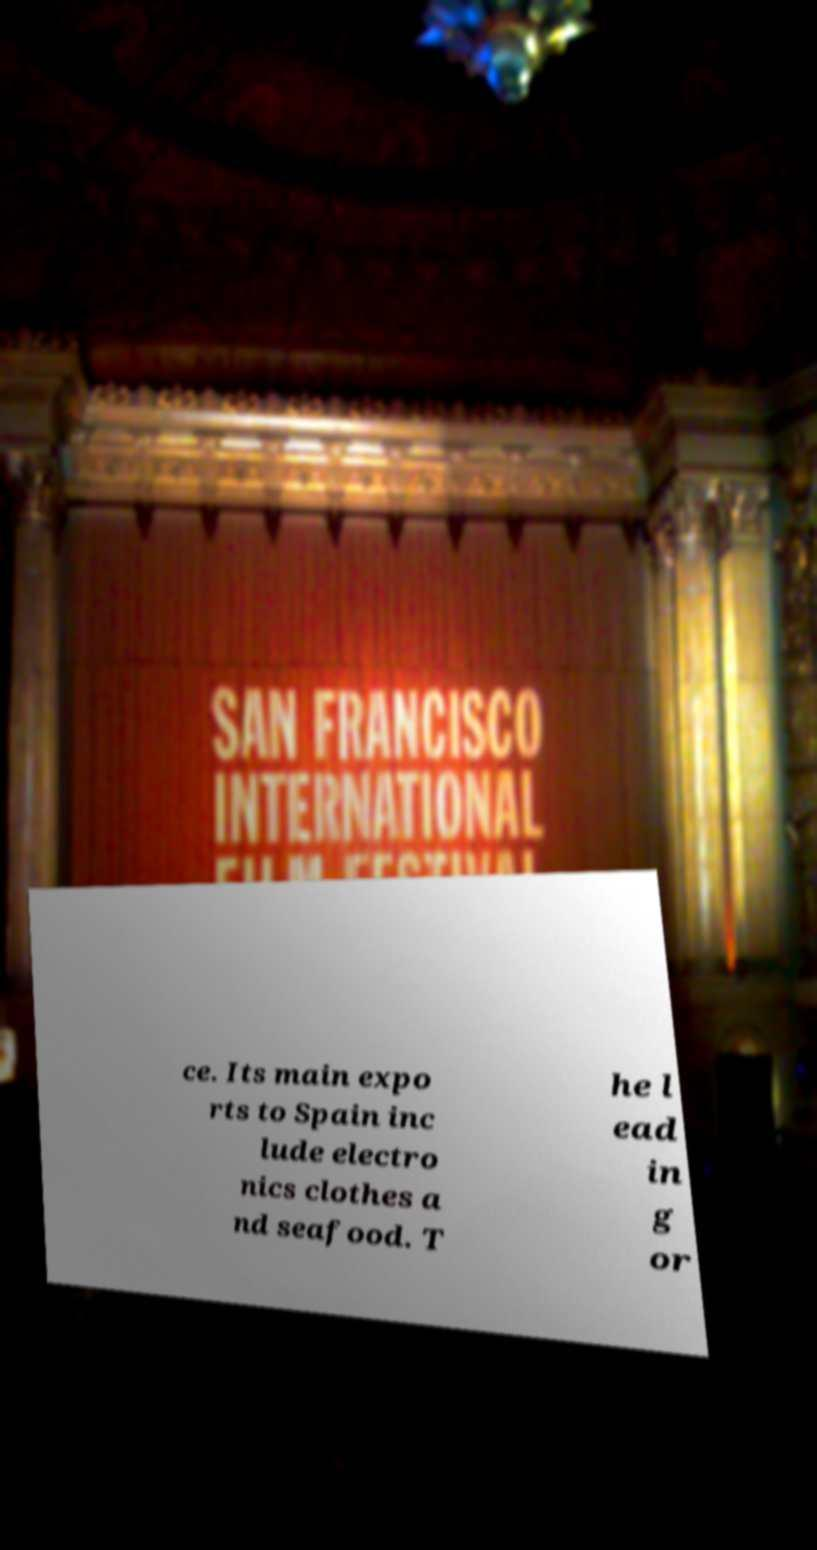Please read and relay the text visible in this image. What does it say? ce. Its main expo rts to Spain inc lude electro nics clothes a nd seafood. T he l ead in g or 